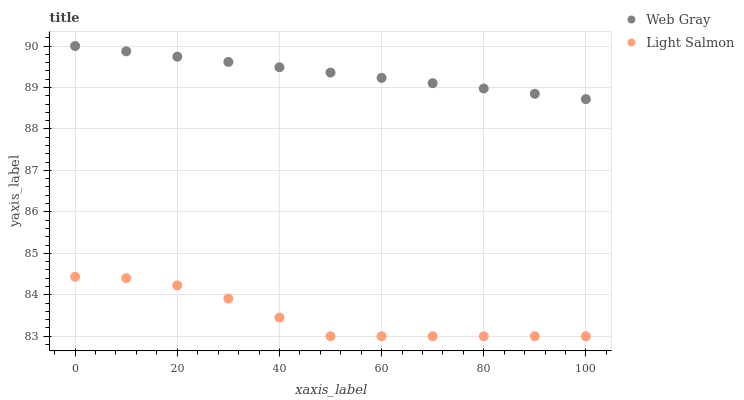Does Light Salmon have the minimum area under the curve?
Answer yes or no. Yes. Does Web Gray have the maximum area under the curve?
Answer yes or no. Yes. Does Web Gray have the minimum area under the curve?
Answer yes or no. No. Is Web Gray the smoothest?
Answer yes or no. Yes. Is Light Salmon the roughest?
Answer yes or no. Yes. Is Web Gray the roughest?
Answer yes or no. No. Does Light Salmon have the lowest value?
Answer yes or no. Yes. Does Web Gray have the lowest value?
Answer yes or no. No. Does Web Gray have the highest value?
Answer yes or no. Yes. Is Light Salmon less than Web Gray?
Answer yes or no. Yes. Is Web Gray greater than Light Salmon?
Answer yes or no. Yes. Does Light Salmon intersect Web Gray?
Answer yes or no. No. 